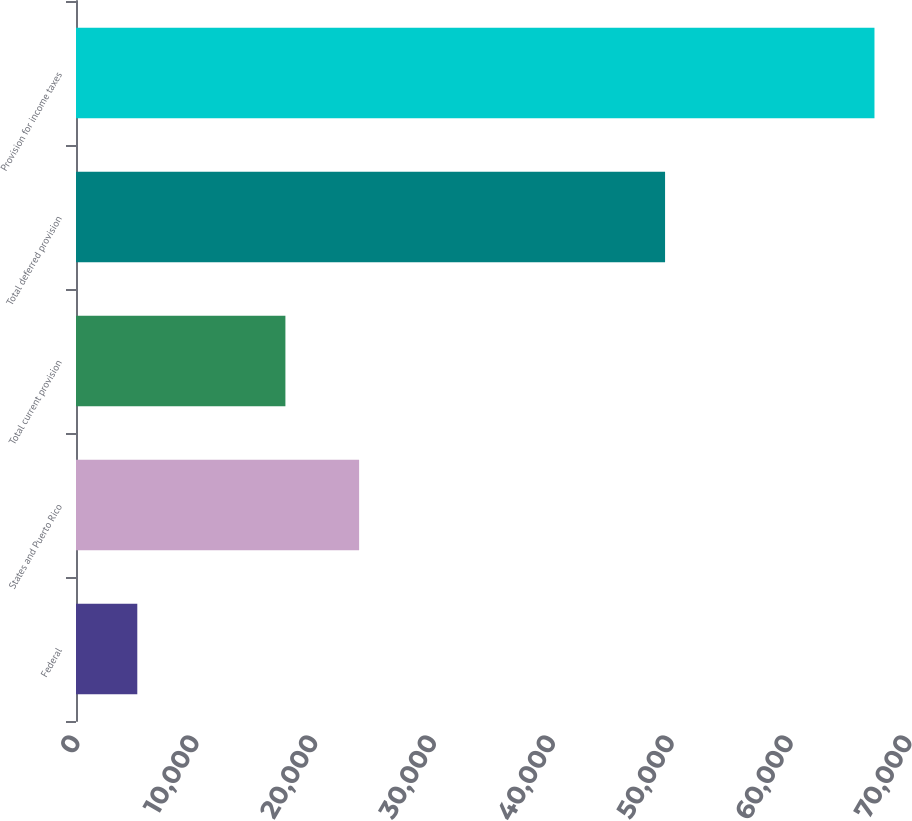Convert chart. <chart><loc_0><loc_0><loc_500><loc_500><bar_chart><fcel>Federal<fcel>States and Puerto Rico<fcel>Total current provision<fcel>Total deferred provision<fcel>Provision for income taxes<nl><fcel>5157<fcel>23820.2<fcel>17618<fcel>49561<fcel>67179<nl></chart> 